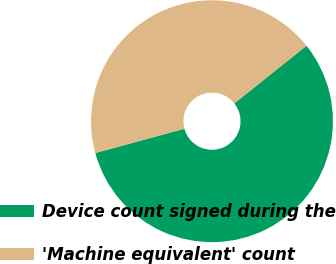Convert chart. <chart><loc_0><loc_0><loc_500><loc_500><pie_chart><fcel>Device count signed during the<fcel>'Machine equivalent' count<nl><fcel>56.49%<fcel>43.51%<nl></chart> 